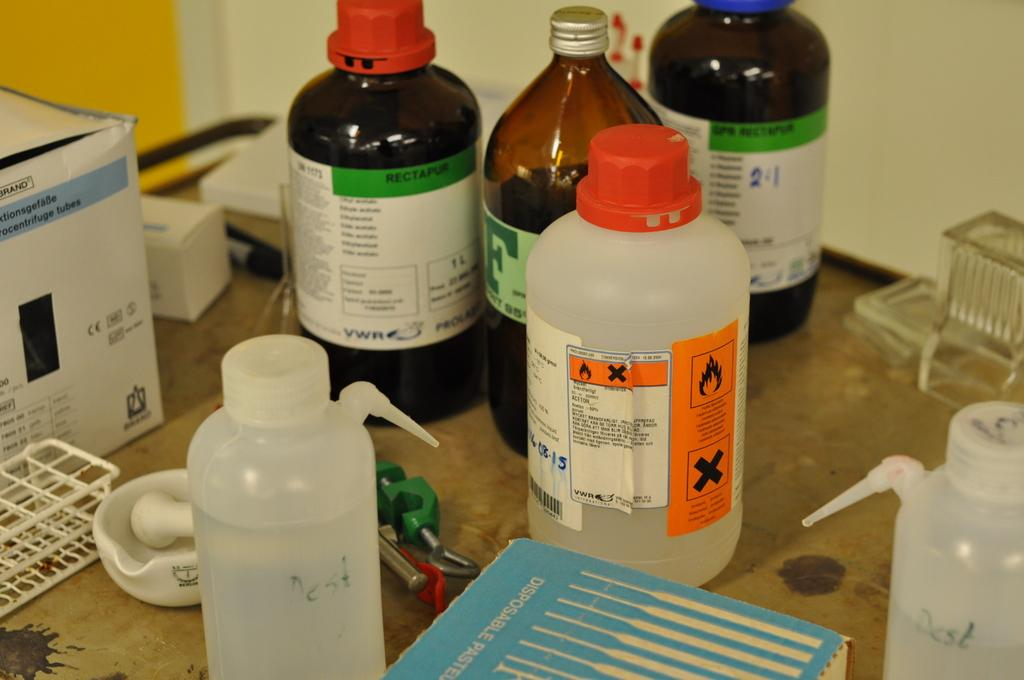<image>
Relay a brief, clear account of the picture shown. A brown bottle has a white label with a green border that says rectapur. 